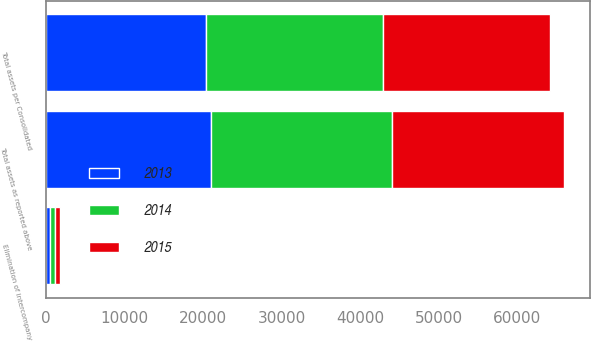Convert chart. <chart><loc_0><loc_0><loc_500><loc_500><stacked_bar_chart><ecel><fcel>Total assets as reported above<fcel>Elimination of intercompany<fcel>Total assets per Consolidated<nl><fcel>2013<fcel>20958<fcel>539<fcel>20419<nl><fcel>2015<fcel>21888<fcel>591<fcel>21297<nl><fcel>2014<fcel>23102<fcel>612<fcel>22490<nl></chart> 